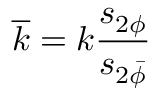<formula> <loc_0><loc_0><loc_500><loc_500>\overline { k } = k \frac { s _ { 2 \phi } } { s _ { 2 \bar { \phi } } }</formula> 